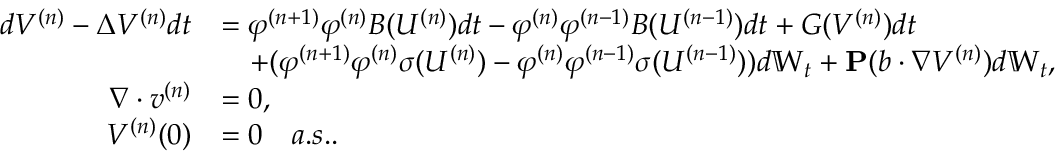<formula> <loc_0><loc_0><loc_500><loc_500>\begin{array} { r l } { d V ^ { ( n ) } - \Delta V ^ { ( n ) } d t } & { = \varphi ^ { ( n + 1 ) } \varphi ^ { ( n ) } B ( U ^ { ( n ) } ) d t - \varphi ^ { ( n ) } \varphi ^ { ( n - 1 ) } B ( U ^ { ( n - 1 ) } ) d t + G ( V ^ { ( n ) } ) d t } \\ & { \quad + ( \varphi ^ { ( n + 1 ) } \varphi ^ { ( n ) } \sigma ( U ^ { ( n ) } ) - \varphi ^ { ( n ) } \varphi ^ { ( n - 1 ) } \sigma ( U ^ { ( n - 1 ) } ) ) d \mathbb { W } _ { t } + P ( b \cdot \nabla V ^ { ( n ) } ) d \mathbb { W } _ { t } , } \\ { \nabla \cdot v ^ { ( n ) } } & { = 0 , } \\ { V ^ { ( n ) } ( 0 ) } & { = 0 \quad a . s . . } \end{array}</formula> 